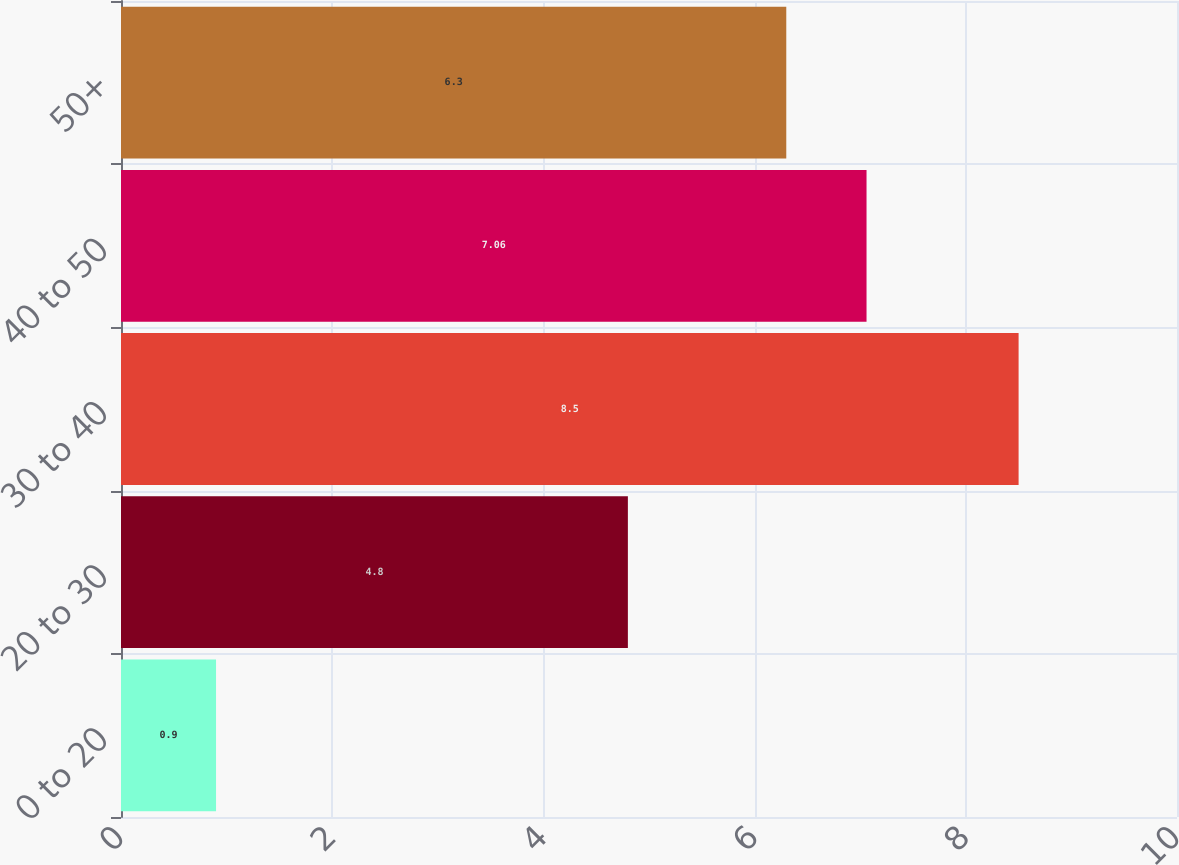Convert chart to OTSL. <chart><loc_0><loc_0><loc_500><loc_500><bar_chart><fcel>0 to 20<fcel>20 to 30<fcel>30 to 40<fcel>40 to 50<fcel>50+<nl><fcel>0.9<fcel>4.8<fcel>8.5<fcel>7.06<fcel>6.3<nl></chart> 